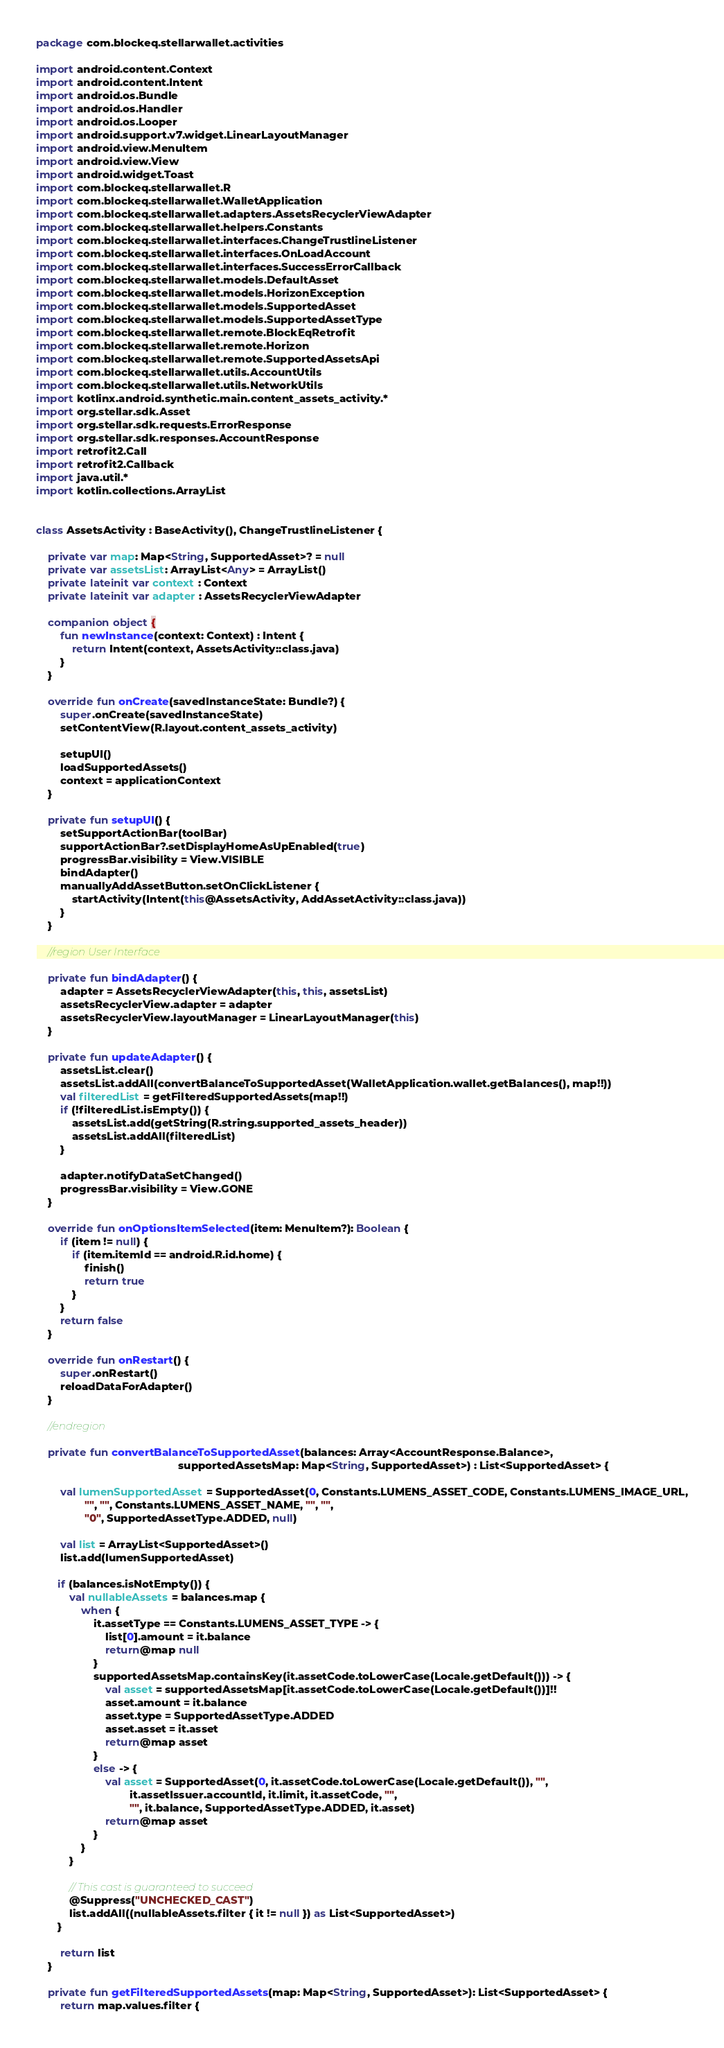Convert code to text. <code><loc_0><loc_0><loc_500><loc_500><_Kotlin_>package com.blockeq.stellarwallet.activities

import android.content.Context
import android.content.Intent
import android.os.Bundle
import android.os.Handler
import android.os.Looper
import android.support.v7.widget.LinearLayoutManager
import android.view.MenuItem
import android.view.View
import android.widget.Toast
import com.blockeq.stellarwallet.R
import com.blockeq.stellarwallet.WalletApplication
import com.blockeq.stellarwallet.adapters.AssetsRecyclerViewAdapter
import com.blockeq.stellarwallet.helpers.Constants
import com.blockeq.stellarwallet.interfaces.ChangeTrustlineListener
import com.blockeq.stellarwallet.interfaces.OnLoadAccount
import com.blockeq.stellarwallet.interfaces.SuccessErrorCallback
import com.blockeq.stellarwallet.models.DefaultAsset
import com.blockeq.stellarwallet.models.HorizonException
import com.blockeq.stellarwallet.models.SupportedAsset
import com.blockeq.stellarwallet.models.SupportedAssetType
import com.blockeq.stellarwallet.remote.BlockEqRetrofit
import com.blockeq.stellarwallet.remote.Horizon
import com.blockeq.stellarwallet.remote.SupportedAssetsApi
import com.blockeq.stellarwallet.utils.AccountUtils
import com.blockeq.stellarwallet.utils.NetworkUtils
import kotlinx.android.synthetic.main.content_assets_activity.*
import org.stellar.sdk.Asset
import org.stellar.sdk.requests.ErrorResponse
import org.stellar.sdk.responses.AccountResponse
import retrofit2.Call
import retrofit2.Callback
import java.util.*
import kotlin.collections.ArrayList


class AssetsActivity : BaseActivity(), ChangeTrustlineListener {

    private var map: Map<String, SupportedAsset>? = null
    private var assetsList: ArrayList<Any> = ArrayList()
    private lateinit var context : Context
    private lateinit var adapter : AssetsRecyclerViewAdapter

    companion object {
        fun newInstance(context: Context) : Intent {
            return Intent(context, AssetsActivity::class.java)
        }
    }

    override fun onCreate(savedInstanceState: Bundle?) {
        super.onCreate(savedInstanceState)
        setContentView(R.layout.content_assets_activity)

        setupUI()
        loadSupportedAssets()
        context = applicationContext
    }

    private fun setupUI() {
        setSupportActionBar(toolBar)
        supportActionBar?.setDisplayHomeAsUpEnabled(true)
        progressBar.visibility = View.VISIBLE
        bindAdapter()
        manuallyAddAssetButton.setOnClickListener {
            startActivity(Intent(this@AssetsActivity, AddAssetActivity::class.java))
        }
    }

    //region User Interface

    private fun bindAdapter() {
        adapter = AssetsRecyclerViewAdapter(this, this, assetsList)
        assetsRecyclerView.adapter = adapter
        assetsRecyclerView.layoutManager = LinearLayoutManager(this)
    }

    private fun updateAdapter() {
        assetsList.clear()
        assetsList.addAll(convertBalanceToSupportedAsset(WalletApplication.wallet.getBalances(), map!!))
        val filteredList = getFilteredSupportedAssets(map!!)
        if (!filteredList.isEmpty()) {
            assetsList.add(getString(R.string.supported_assets_header))
            assetsList.addAll(filteredList)
        }

        adapter.notifyDataSetChanged()
        progressBar.visibility = View.GONE
    }

    override fun onOptionsItemSelected(item: MenuItem?): Boolean {
        if (item != null) {
            if (item.itemId == android.R.id.home) {
                finish()
                return true
            }
        }
        return false
    }

    override fun onRestart() {
        super.onRestart()
        reloadDataForAdapter()
    }

    //endregion

    private fun convertBalanceToSupportedAsset(balances: Array<AccountResponse.Balance>,
                                               supportedAssetsMap: Map<String, SupportedAsset>) : List<SupportedAsset> {

        val lumenSupportedAsset = SupportedAsset(0, Constants.LUMENS_ASSET_CODE, Constants.LUMENS_IMAGE_URL,
                "", "", Constants.LUMENS_ASSET_NAME, "", "",
                "0", SupportedAssetType.ADDED, null)

        val list = ArrayList<SupportedAsset>()
        list.add(lumenSupportedAsset)

       if (balances.isNotEmpty()) {
           val nullableAssets = balances.map {
               when {
                   it.assetType == Constants.LUMENS_ASSET_TYPE -> {
                       list[0].amount = it.balance
                       return@map null
                   }
                   supportedAssetsMap.containsKey(it.assetCode.toLowerCase(Locale.getDefault())) -> {
                       val asset = supportedAssetsMap[it.assetCode.toLowerCase(Locale.getDefault())]!!
                       asset.amount = it.balance
                       asset.type = SupportedAssetType.ADDED
                       asset.asset = it.asset
                       return@map asset
                   }
                   else -> {
                       val asset = SupportedAsset(0, it.assetCode.toLowerCase(Locale.getDefault()), "",
                               it.assetIssuer.accountId, it.limit, it.assetCode, "",
                               "", it.balance, SupportedAssetType.ADDED, it.asset)
                       return@map asset
                   }
               }
           }

           // This cast is guaranteed to succeed
           @Suppress("UNCHECKED_CAST")
           list.addAll((nullableAssets.filter { it != null }) as List<SupportedAsset>)
       }

        return list
    }

    private fun getFilteredSupportedAssets(map: Map<String, SupportedAsset>): List<SupportedAsset> {
        return map.values.filter {</code> 